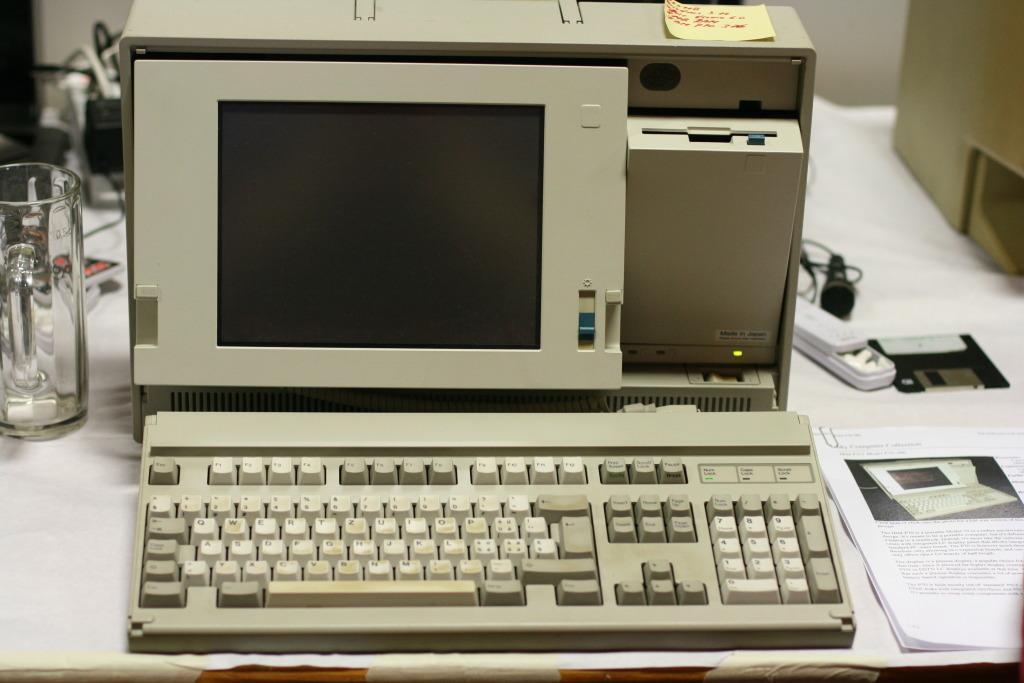Can you describe this image briefly? In this picture we can see a platform, on this platform we can see a monitor, keyboard, CPU, glass, battery, mic, papers and some objects and we can see a wall in the background. 